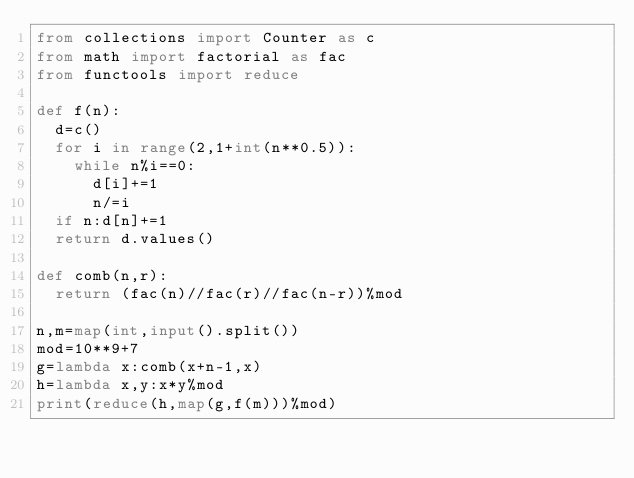<code> <loc_0><loc_0><loc_500><loc_500><_Python_>from collections import Counter as c
from math import factorial as fac
from functools import reduce

def f(n):
  d=c()
  for i in range(2,1+int(n**0.5)):
    while n%i==0:
      d[i]+=1
      n/=i
  if n:d[n]+=1
  return d.values()

def comb(n,r):
  return (fac(n)//fac(r)//fac(n-r))%mod

n,m=map(int,input().split())
mod=10**9+7
g=lambda x:comb(x+n-1,x)
h=lambda x,y:x*y%mod
print(reduce(h,map(g,f(m)))%mod)</code> 